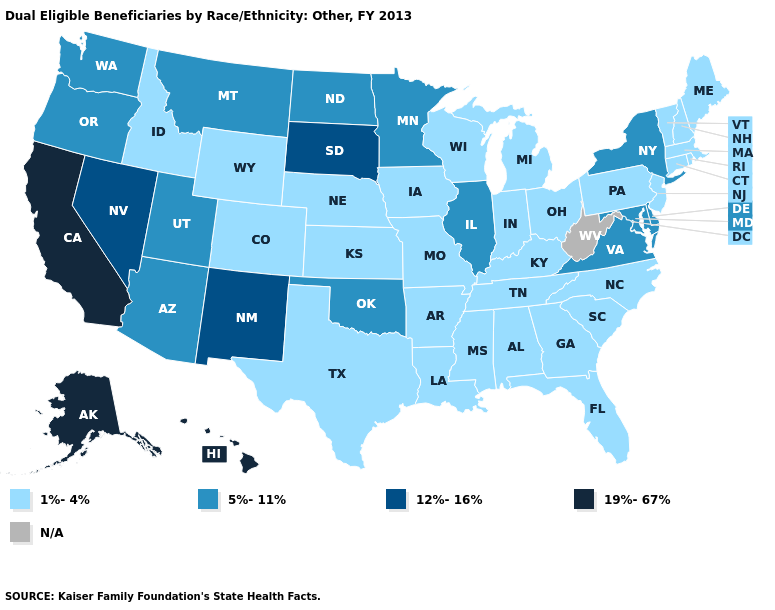What is the value of Massachusetts?
Give a very brief answer. 1%-4%. What is the highest value in the South ?
Give a very brief answer. 5%-11%. What is the value of Missouri?
Write a very short answer. 1%-4%. Among the states that border Virginia , which have the lowest value?
Quick response, please. Kentucky, North Carolina, Tennessee. Name the states that have a value in the range 5%-11%?
Give a very brief answer. Arizona, Delaware, Illinois, Maryland, Minnesota, Montana, New York, North Dakota, Oklahoma, Oregon, Utah, Virginia, Washington. How many symbols are there in the legend?
Answer briefly. 5. Name the states that have a value in the range 5%-11%?
Write a very short answer. Arizona, Delaware, Illinois, Maryland, Minnesota, Montana, New York, North Dakota, Oklahoma, Oregon, Utah, Virginia, Washington. How many symbols are there in the legend?
Write a very short answer. 5. Does Colorado have the lowest value in the West?
Short answer required. Yes. How many symbols are there in the legend?
Short answer required. 5. Name the states that have a value in the range 19%-67%?
Be succinct. Alaska, California, Hawaii. What is the value of Hawaii?
Short answer required. 19%-67%. Which states have the highest value in the USA?
Short answer required. Alaska, California, Hawaii. 